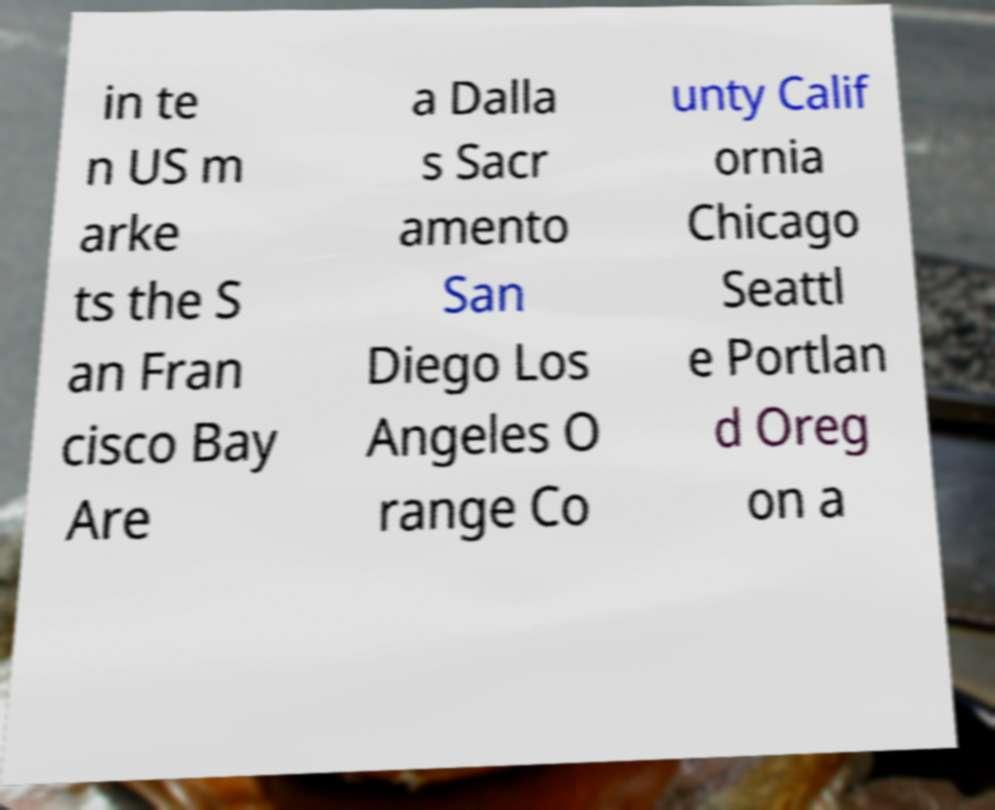Could you extract and type out the text from this image? in te n US m arke ts the S an Fran cisco Bay Are a Dalla s Sacr amento San Diego Los Angeles O range Co unty Calif ornia Chicago Seattl e Portlan d Oreg on a 